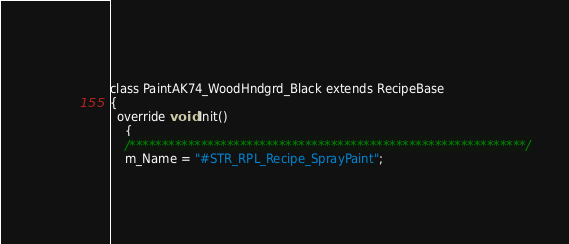<code> <loc_0><loc_0><loc_500><loc_500><_C_>class PaintAK74_WoodHndgrd_Black extends RecipeBase
{
  override void Init()
	{
    /*************************************************************/
    m_Name = "#STR_RPL_Recipe_SprayPaint";</code> 